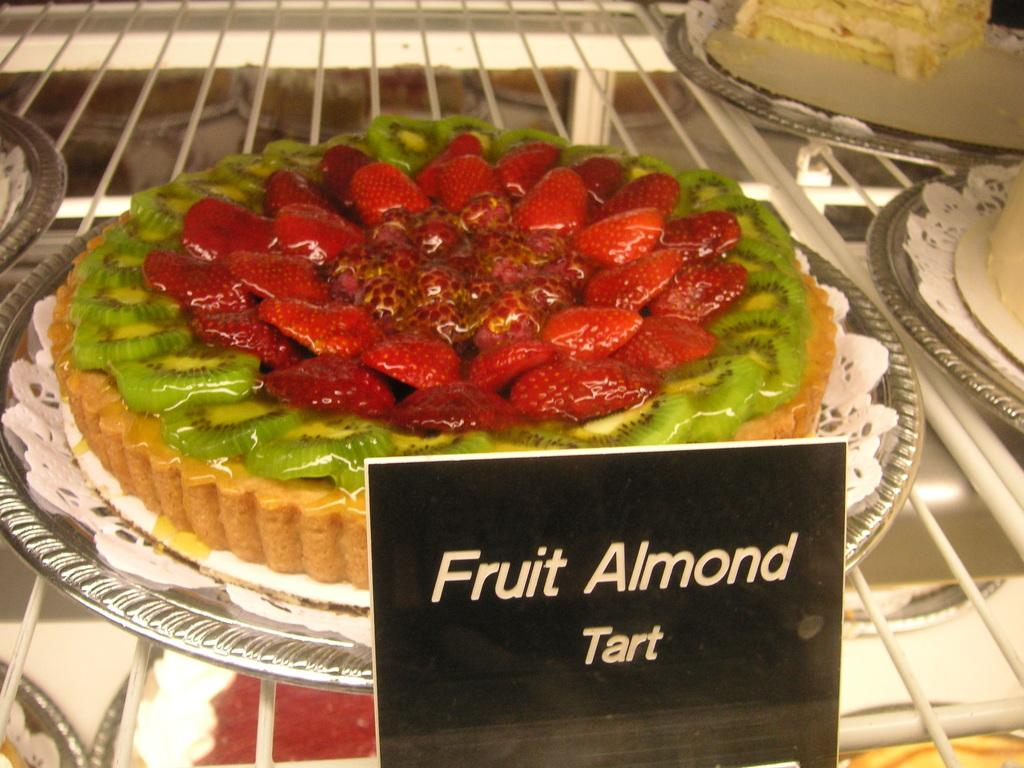What types of desserts can be seen in the image? There are different types of cakes in the image. Where are the cakes located? The cakes are placed on a table. How can you identify the cakes in the image? There are name boards associated with the cakes. What committee is responsible for setting the limit on the number of cakes in the image? There is no mention of a committee or limit on the number of cakes in the image. The image simply shows different types of cakes placed on a table with name boards. 